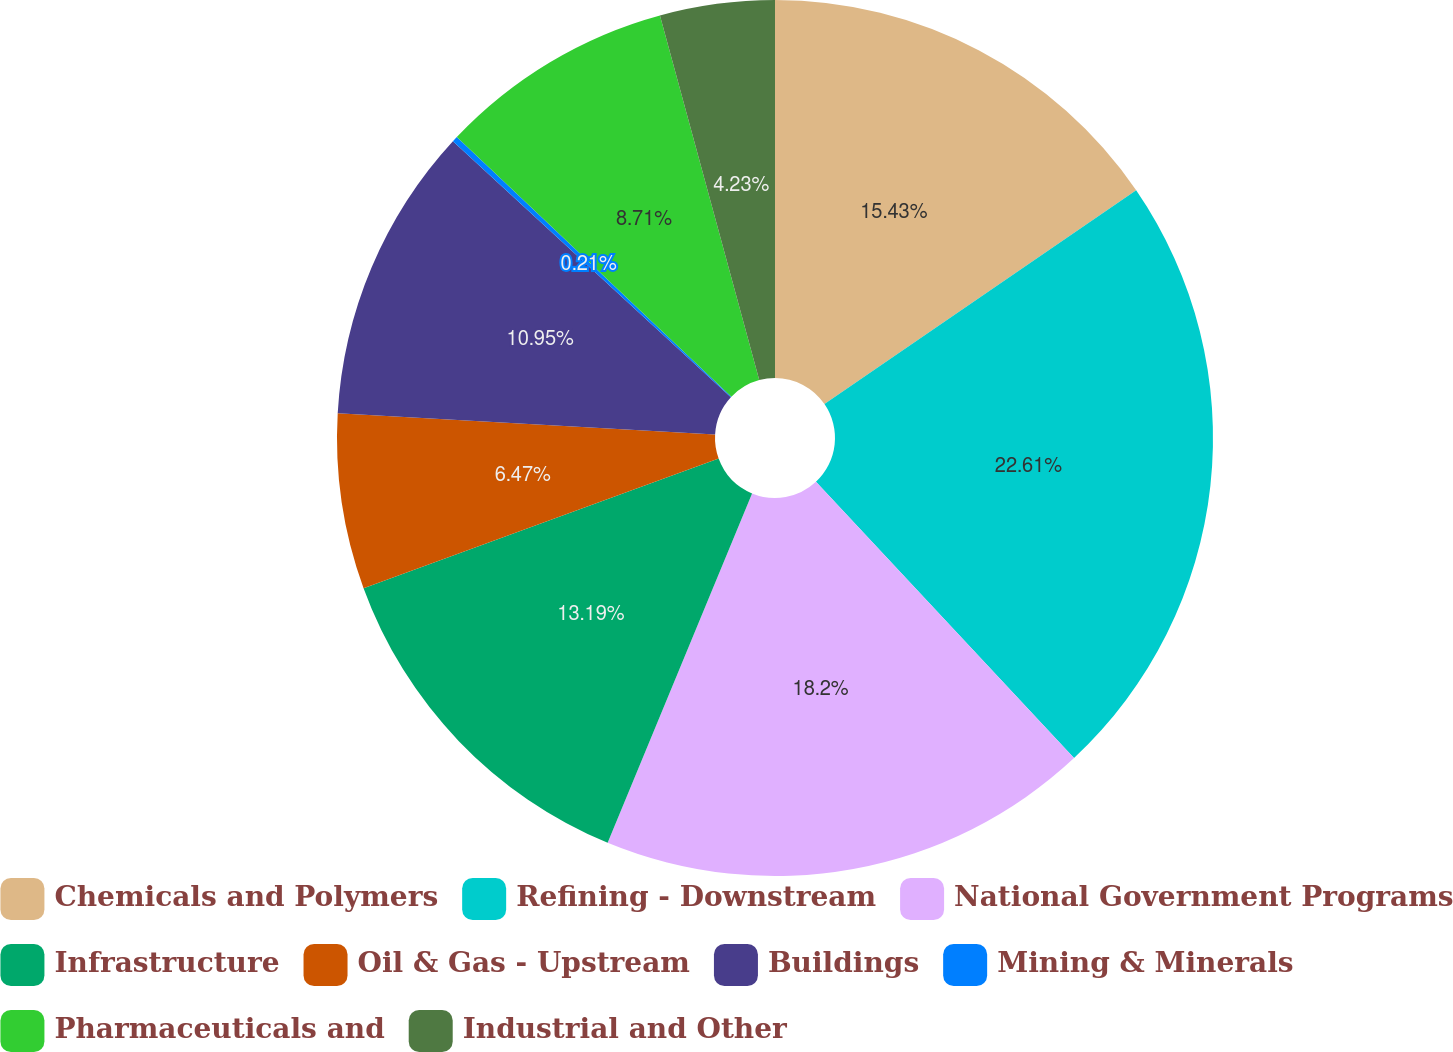Convert chart. <chart><loc_0><loc_0><loc_500><loc_500><pie_chart><fcel>Chemicals and Polymers<fcel>Refining - Downstream<fcel>National Government Programs<fcel>Infrastructure<fcel>Oil & Gas - Upstream<fcel>Buildings<fcel>Mining & Minerals<fcel>Pharmaceuticals and<fcel>Industrial and Other<nl><fcel>15.43%<fcel>22.61%<fcel>18.2%<fcel>13.19%<fcel>6.47%<fcel>10.95%<fcel>0.21%<fcel>8.71%<fcel>4.23%<nl></chart> 